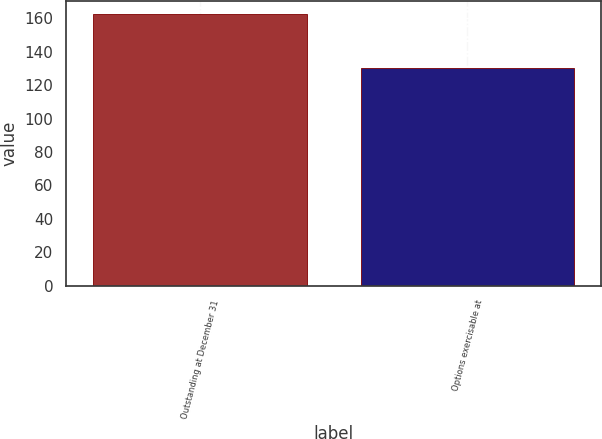Convert chart to OTSL. <chart><loc_0><loc_0><loc_500><loc_500><bar_chart><fcel>Outstanding at December 31<fcel>Options exercisable at<nl><fcel>162.29<fcel>130.15<nl></chart> 